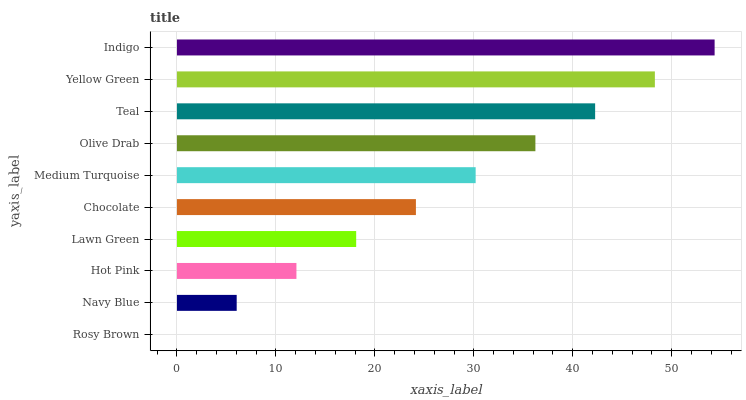Is Rosy Brown the minimum?
Answer yes or no. Yes. Is Indigo the maximum?
Answer yes or no. Yes. Is Navy Blue the minimum?
Answer yes or no. No. Is Navy Blue the maximum?
Answer yes or no. No. Is Navy Blue greater than Rosy Brown?
Answer yes or no. Yes. Is Rosy Brown less than Navy Blue?
Answer yes or no. Yes. Is Rosy Brown greater than Navy Blue?
Answer yes or no. No. Is Navy Blue less than Rosy Brown?
Answer yes or no. No. Is Medium Turquoise the high median?
Answer yes or no. Yes. Is Chocolate the low median?
Answer yes or no. Yes. Is Navy Blue the high median?
Answer yes or no. No. Is Lawn Green the low median?
Answer yes or no. No. 